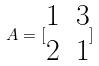<formula> <loc_0><loc_0><loc_500><loc_500>A = [ \begin{matrix} 1 & 3 \\ 2 & 1 \end{matrix} ]</formula> 